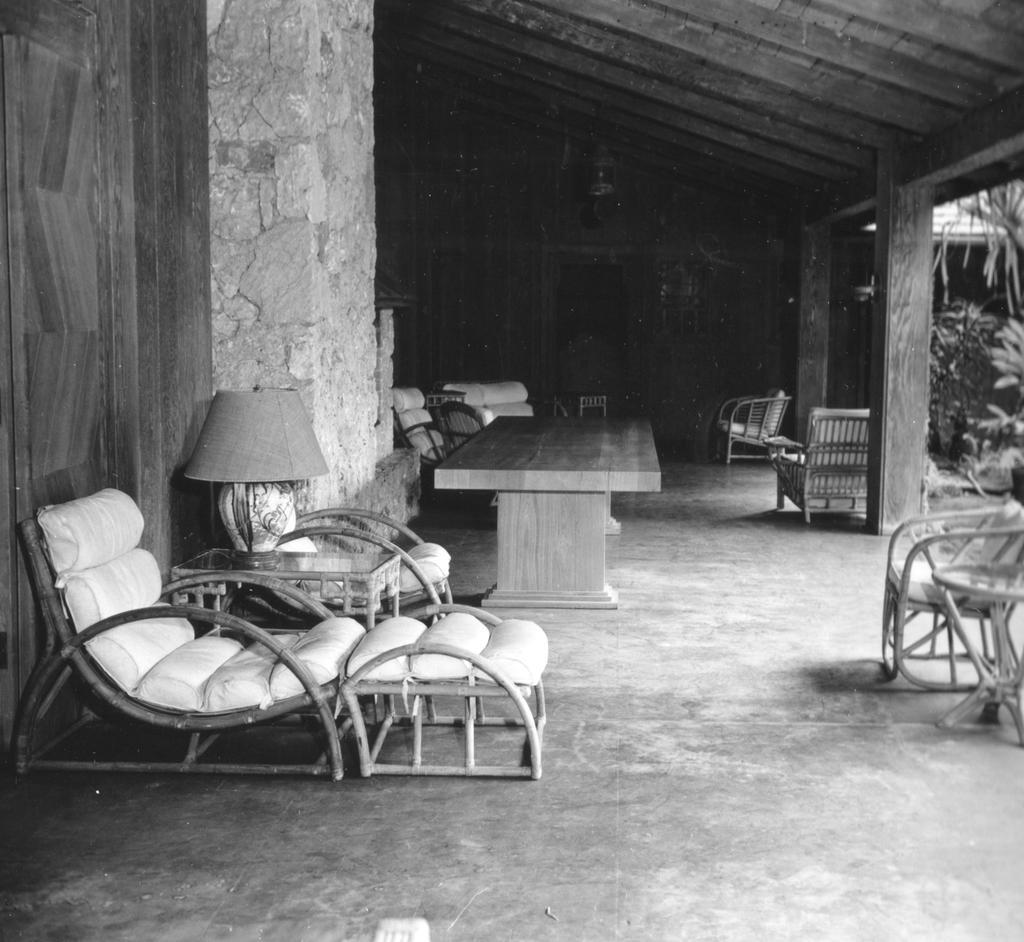Describe this image in one or two sentences. In this image we can see the table lamp, chairs and the tables. And we can see a shed and the pillars. On the right, we can see some plants. 